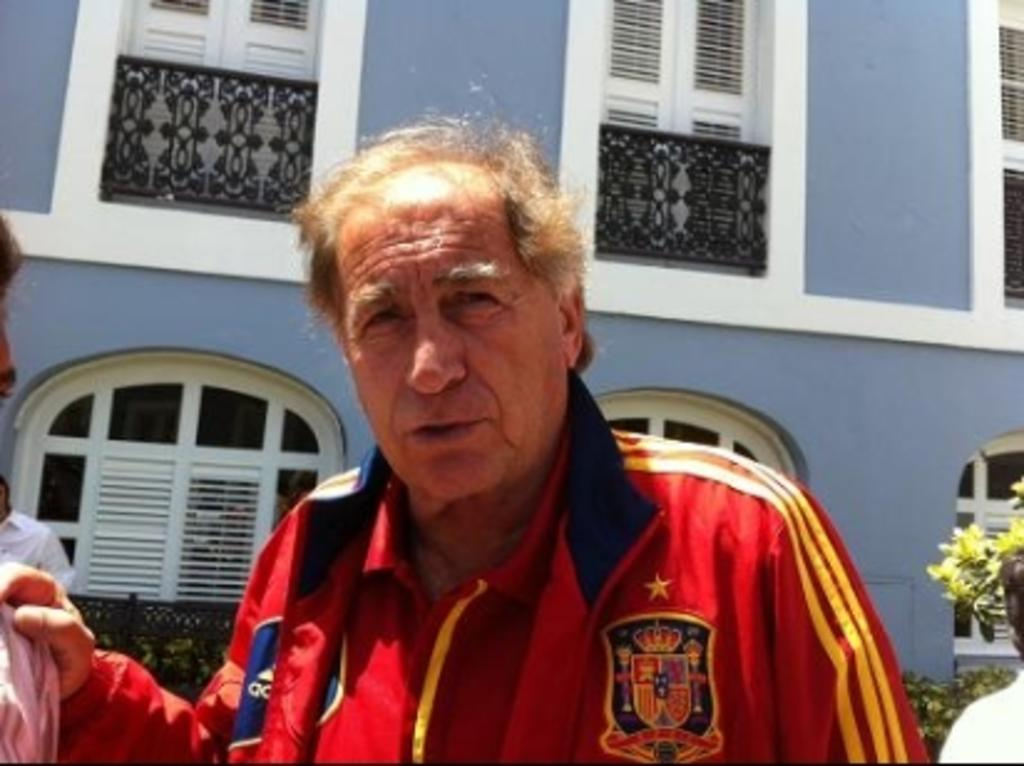What can be seen in the front of the image? There are people standing in the front of the image. What is separating the people from the background? There is a fence in the image. What type of vegetation is present in the image? There are plants and a tree in the image. What type of structure is visible in the image? There is a building in the image. What architectural feature can be seen on the building? There are windows in the image. What type of jam is being spread on the fence in the image? There is no jam present in the image; it features people, a fence, plants, a tree, a building, and windows. What need does the tree have in the image? The tree does not have any specific need in the image; it is simply a part of the landscape. 